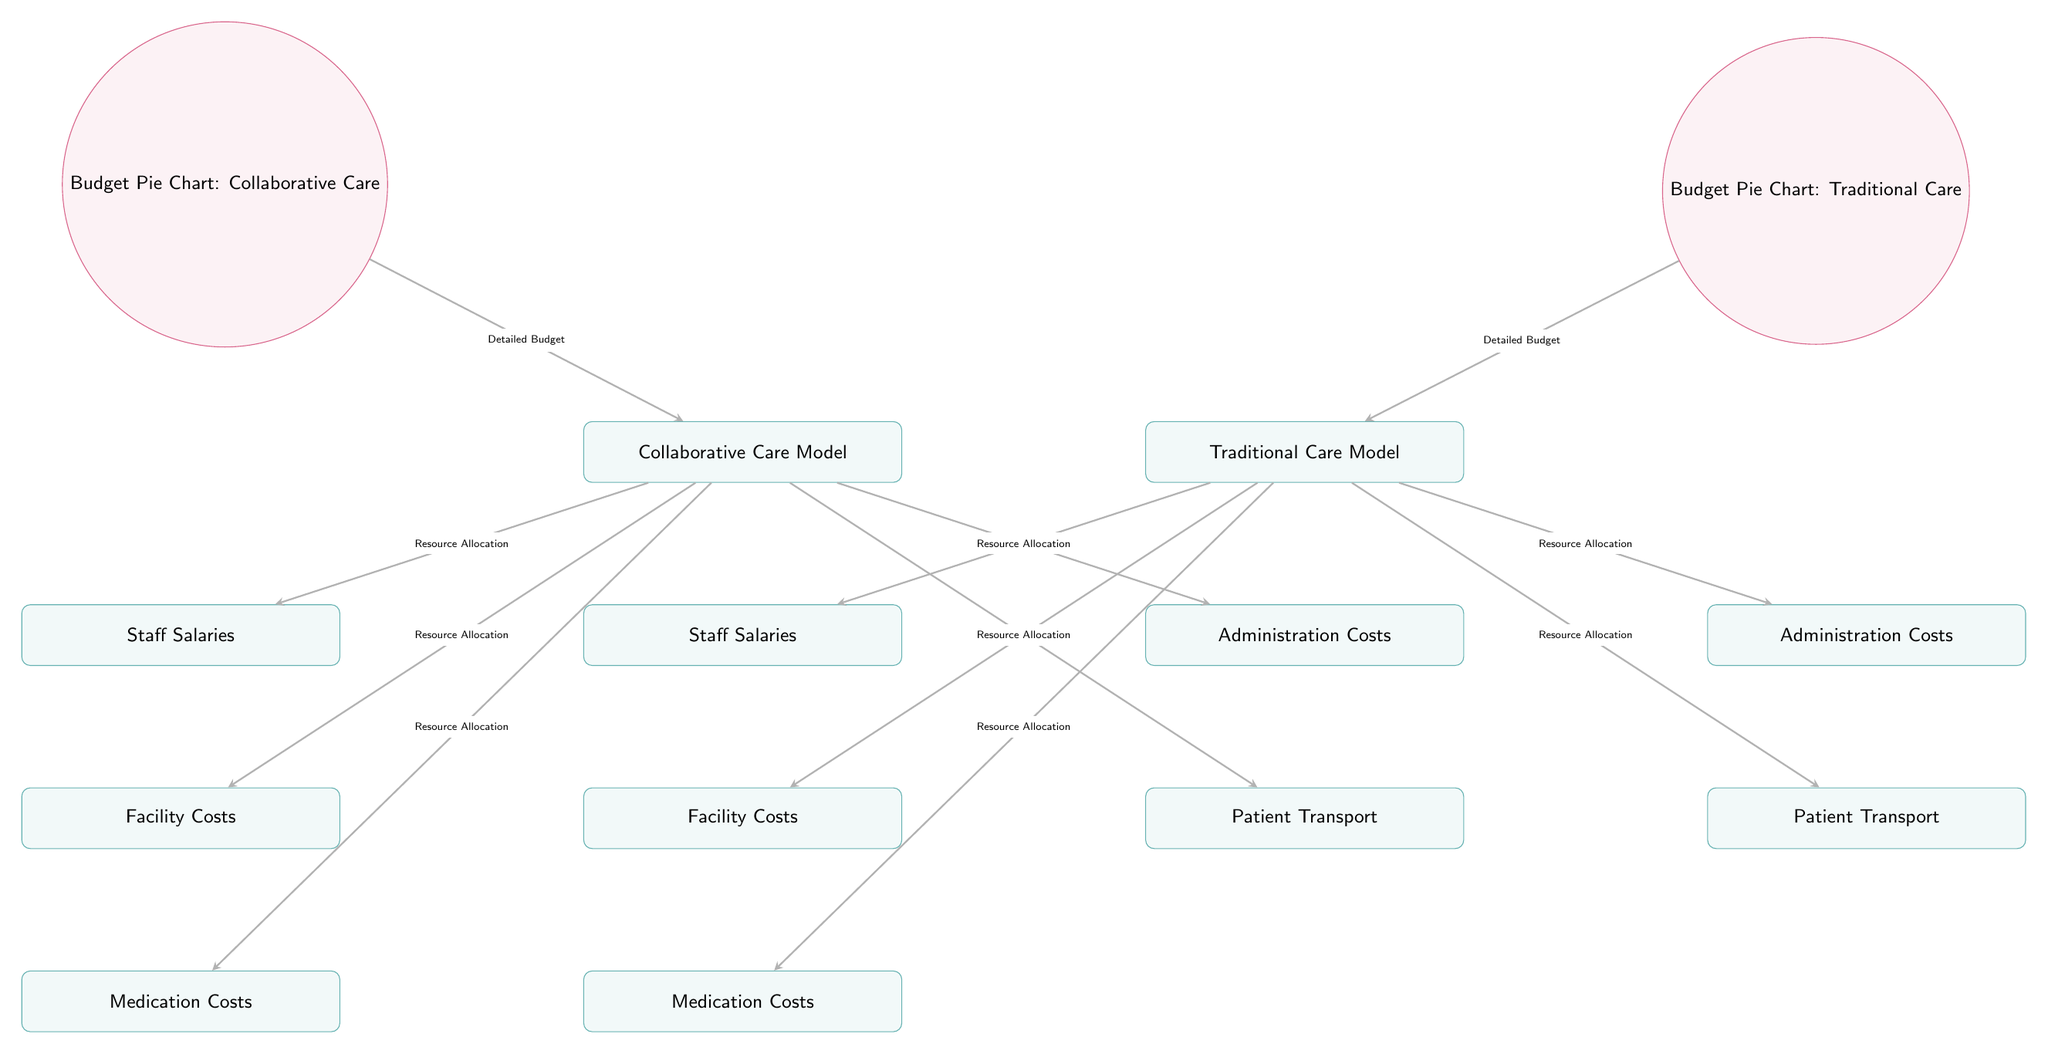What are the two care models compared in the diagram? The diagram compares the Collaborative Care Model and the Traditional Care Model, which are indicated as the main nodes in the diagram.
Answer: Collaborative Care Model, Traditional Care Model How many categories of resource allocation are listed for each care model? Each care model has five distinct categories shown beneath them, which are labeled as Staff Salaries, Facility Costs, Medication Costs, Administration Costs, and Patient Transport.
Answer: 5 What resource allocation category is positioned directly below 'Collaborative Care Model'? The category directly below the Collaborative Care Model is Staff Salaries, as indicated in the diagram layout.
Answer: Staff Salaries Which type of care incurs higher administration costs as inferred from the diagram? The diagram implies that Traditional Care Model typically requires more resources for administration based on the structure and size of the resource allocation beneath it compared to Collaborative Care.
Answer: Traditional Care Model What is the relationship between the pie charts and the care models? The pie charts labeled as Budget Pie Chart for each model show the detailed budget associated with Collaborative Care and Traditional Care, visually linking them to their respective models.
Answer: Detailed Budget Which model has the pie chart positioned to its left? The pie chart labeled as Budget Pie Chart for Collaborative Care is positioned to the left of its model, indicating it relates directly to Collaborative Care.
Answer: Collaborative Care Model How do the arrows function in the diagram? Arrows represent the direction of resource allocation from each care model to its respective categories and also show the connection to the detailed budget represented by the pie charts.
Answer: Indicate Resource Allocation Which resource allocation category is the last one listed for both models? For both care models, the last category listed at the bottom is Patient Transport, which is consistent in the resource allocation structure for both models.
Answer: Patient Transport What does the diagram emphasize by featuring the two different models? The diagram emphasizes a comparative analysis of resource allocation and cost breakdown between Collaborative and Traditional Care Models for high-risk pregnancies, highlighting distinctions in healthcare approaches.
Answer: Comparative Analysis 